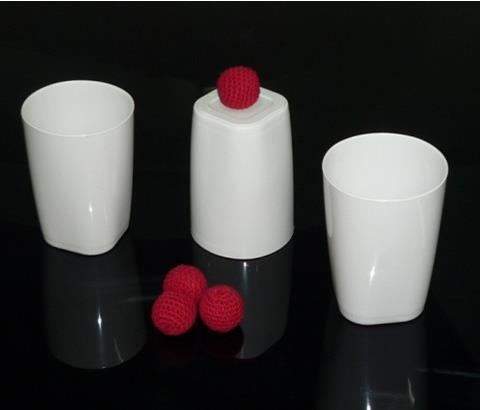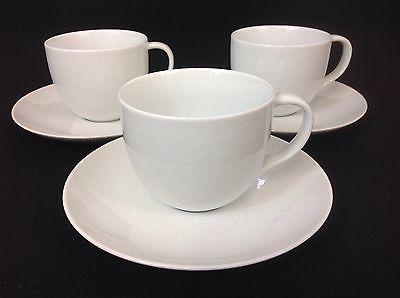The first image is the image on the left, the second image is the image on the right. Considering the images on both sides, is "There are 3 white coffee cups and saucers" valid? Answer yes or no. Yes. The first image is the image on the left, the second image is the image on the right. For the images shown, is this caption "The right image has three empty white coffee cups." true? Answer yes or no. Yes. 